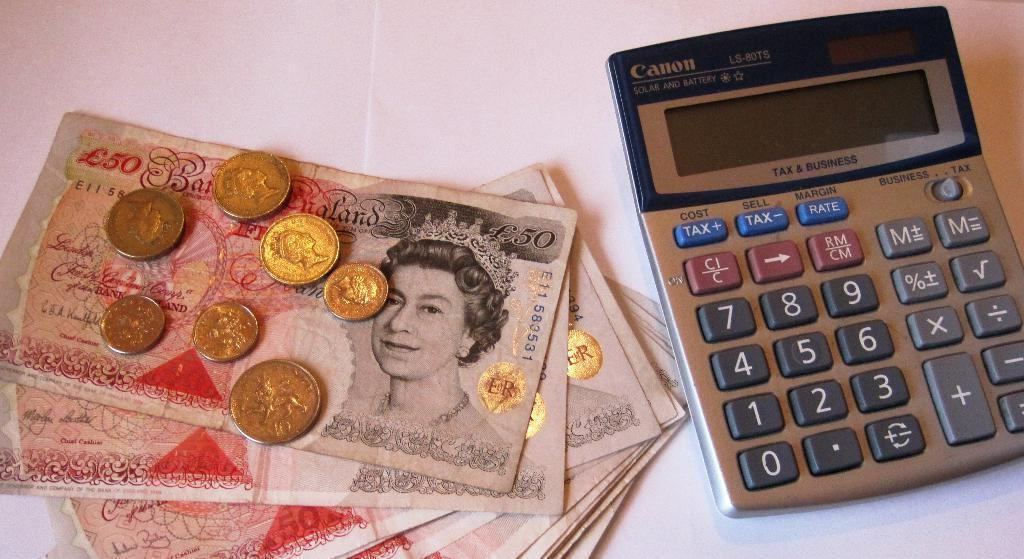<image>
Create a compact narrative representing the image presented. A pile of money that says 50 on it is next to a Canon calculator. 